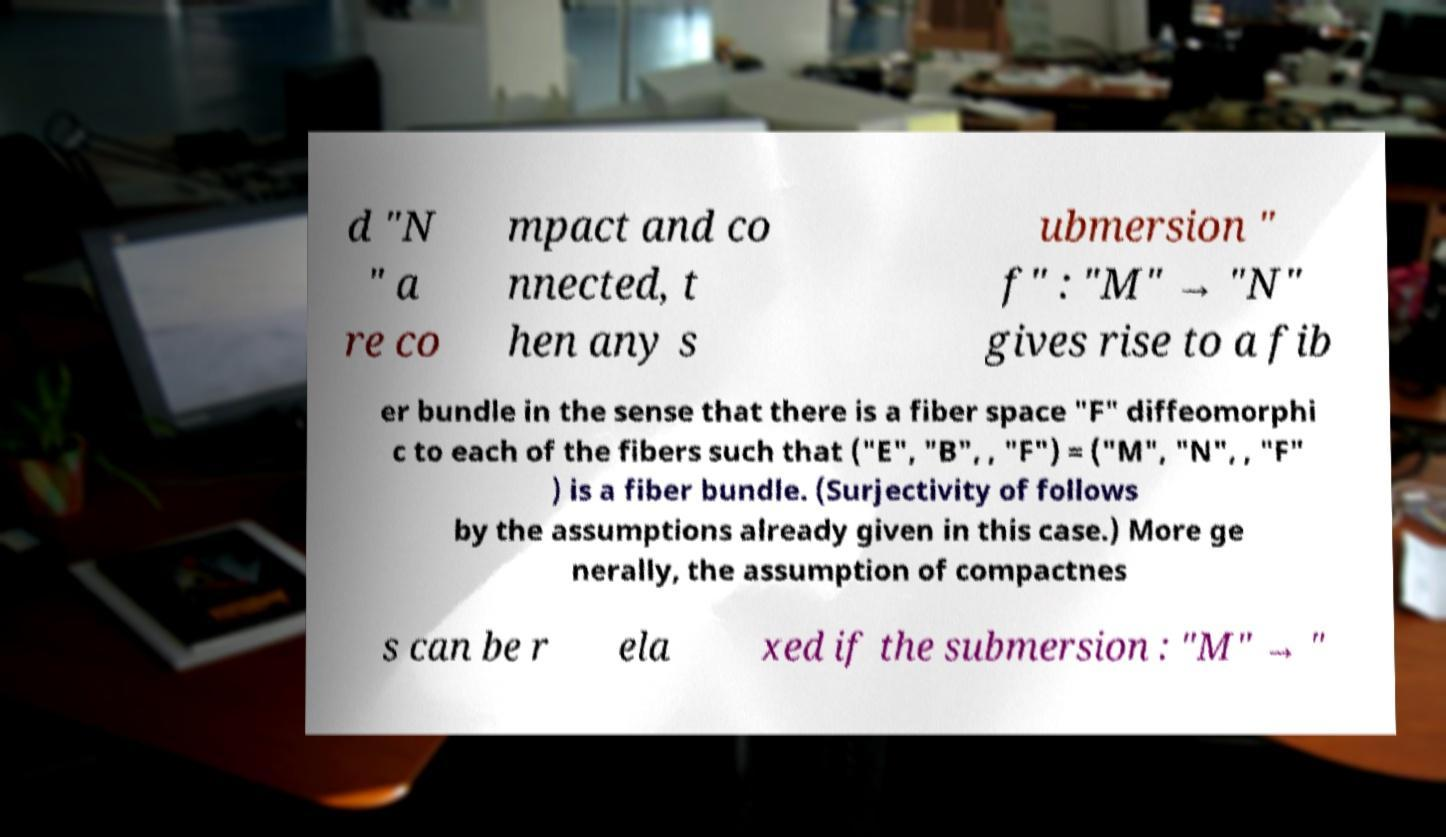Could you extract and type out the text from this image? d "N " a re co mpact and co nnected, t hen any s ubmersion " f" : "M" → "N" gives rise to a fib er bundle in the sense that there is a fiber space "F" diffeomorphi c to each of the fibers such that ("E", "B", , "F") = ("M", "N", , "F" ) is a fiber bundle. (Surjectivity of follows by the assumptions already given in this case.) More ge nerally, the assumption of compactnes s can be r ela xed if the submersion : "M" → " 